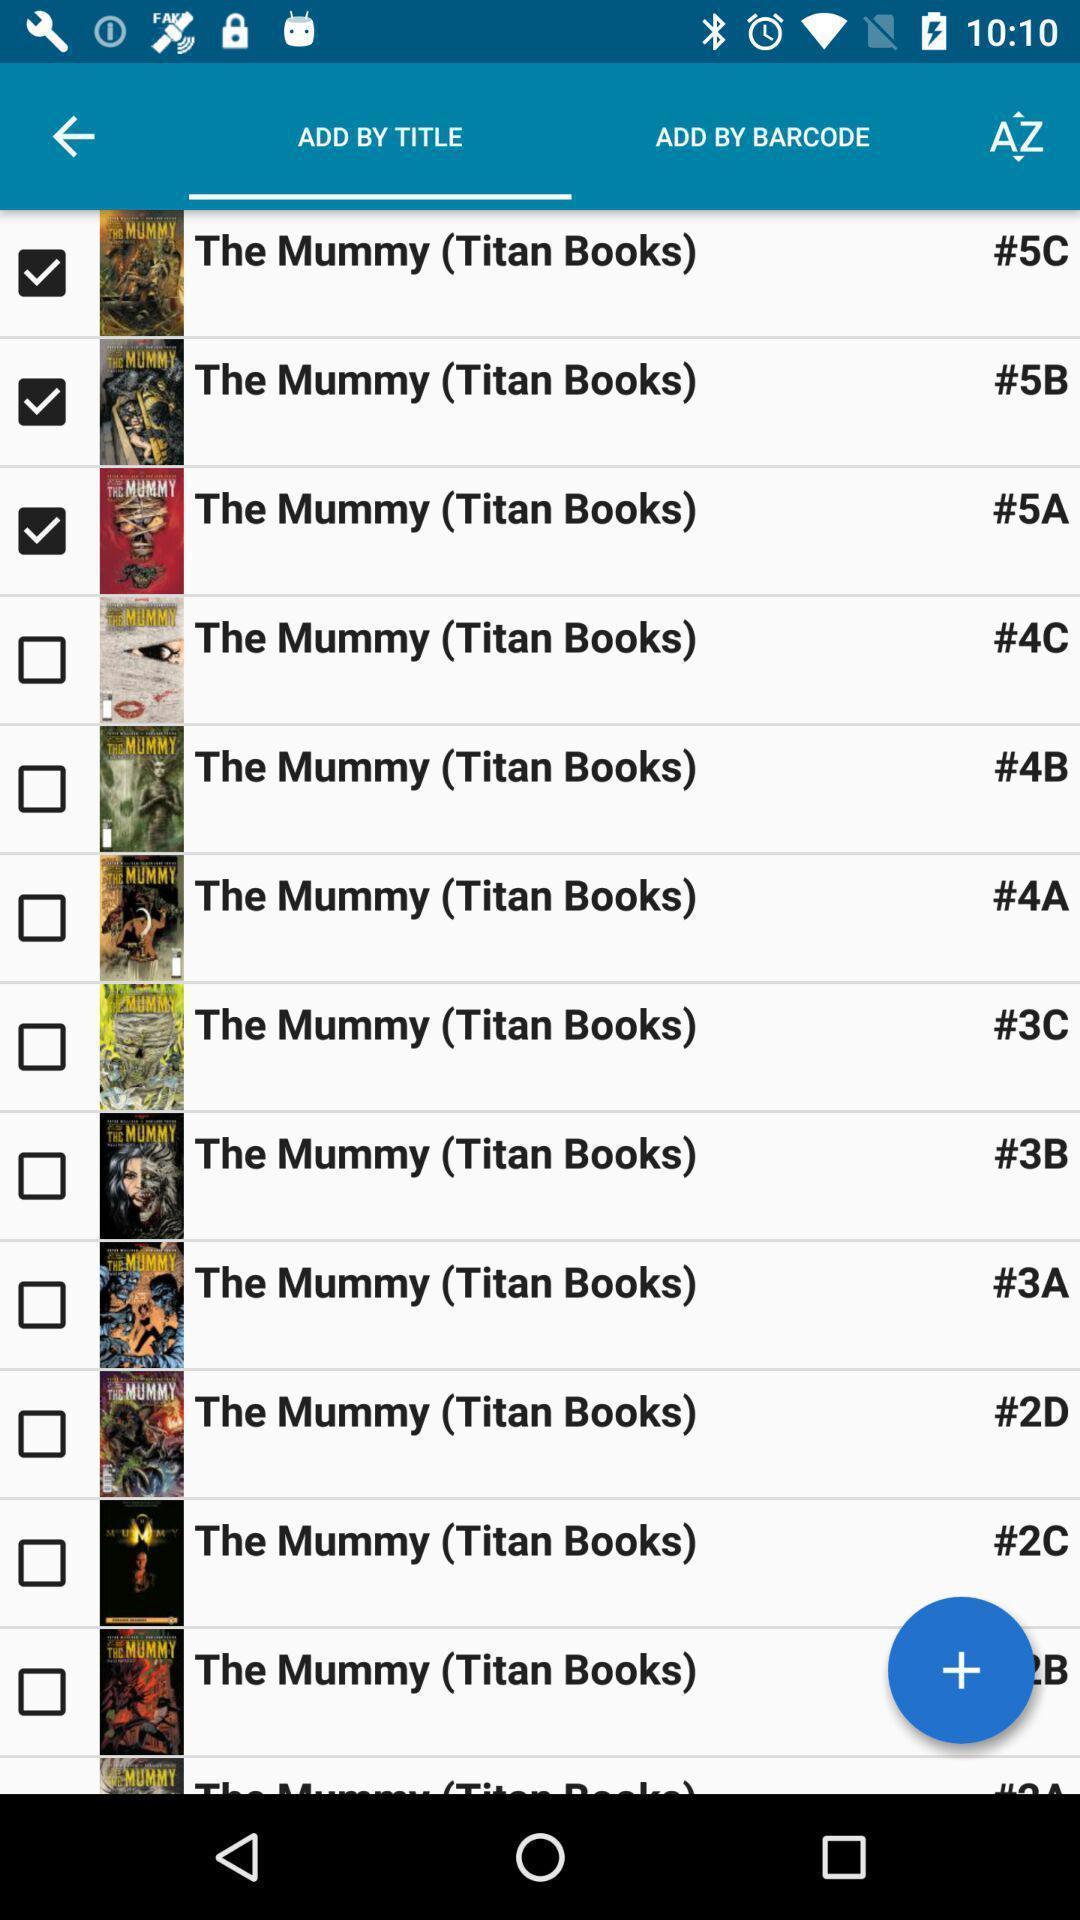Tell me what you see in this picture. Screen shows list of books. 